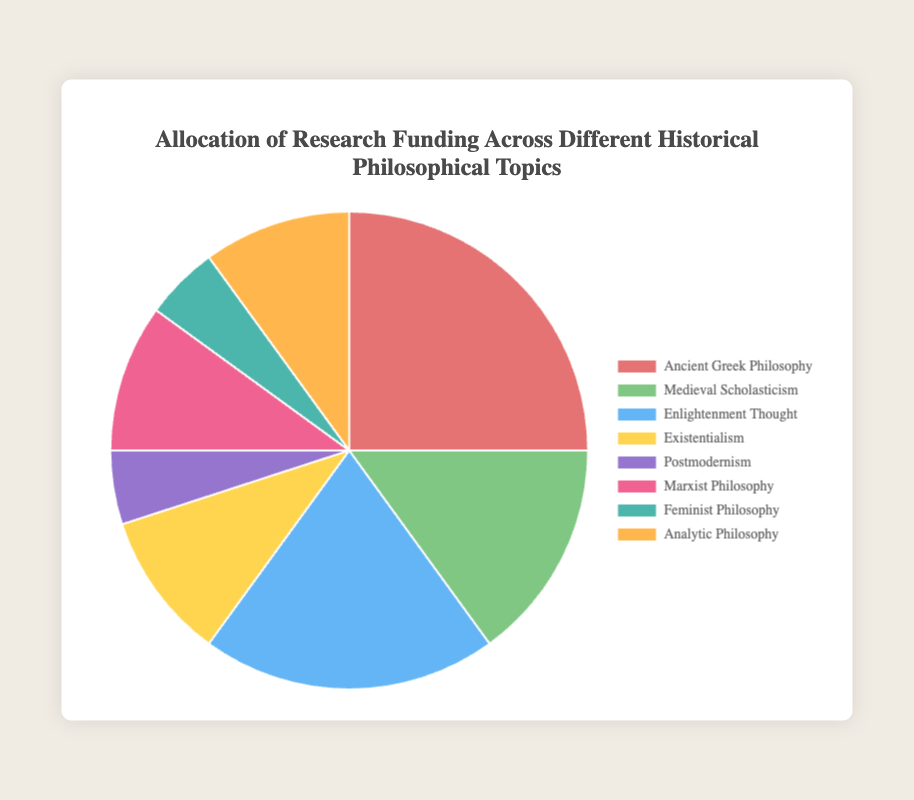Which philosophical topic received the highest percentage of research funding? Ancient Greek Philosophy received the highest percentage of funding at 25%.
Answer: Ancient Greek Philosophy Which two philosophical topics together received a combined funding percentage equal to that of Ancient Greek Philosophy? Existentialism and Analytic Philosophy each received 10% funding, and combining (10% + 10%) matches the 20% funding for Enlightenment Thought.
Answer: Enlightenment Thought How much more funding percentage does Enlightenment Thought have compared to Medieval Scholasticism? Enlightenment Thought has 20% funding, while Medieval Scholasticism has 15%. The difference is 20% - 15% = 5%.
Answer: 5% Which topic received the least funding, and what was its percentage? Both Postmodernism and Feminist Philosophy received the least amount of funding, each at 5%.
Answer: Postmodernism and Feminist Philosophy How much combined funding percentage is allocated to Existentialism, Marxist Philosophy, and Feminist Philosophy? Existentialism, Marxist Philosophy, and Feminist Philosophy received 10%, 10%, and 5% respectively. The combined percentage is 10% + 10% + 5% = 25%.
Answer: 25% Which philosophical topic's funding is represented by the green color in the pie chart? The green color represents Medieval Scholasticism which received 15% funding.
Answer: Medieval Scholasticism Compare the funding percentages of Marxist Philosophy and Analytic Philosophy. Which one received more funding? Both Marxist Philosophy and Analytic Philosophy received the same funding percentage, each at 10%.
Answer: Equal How much more funding percentage does Ancient Greek Philosophy have compared to Feminist Philosophy? Ancient Greek Philosophy received 25% funding, while Feminist Philosophy received 5%. The difference is 25% - 5% = 20%.
Answer: 20% What is the percentage difference between the funding for Enlightenment Thought and Postmodernism? Enlightenment Thought received 20% funding, while Postmodernism received 5%. The difference is 20% - 5% = 15%.
Answer: 15% How many topics received a funding percentage of 10% or more? Ancient Greek Philosophy (25%), Medieval Scholasticism (15%), Enlightenment Thought (20%), Existentialism (10%), Marxist Philosophy (10%), and Analytic Philosophy (10%) received 10% or more. There are six topics in total.
Answer: 6 